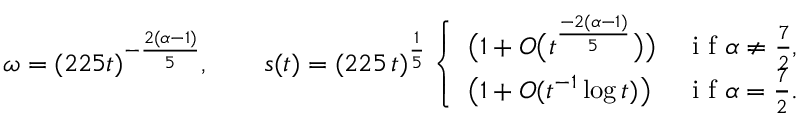Convert formula to latex. <formula><loc_0><loc_0><loc_500><loc_500>\omega = ( 2 2 5 t ) ^ { - \frac { 2 ( \alpha - 1 ) } { 5 } } , \quad s ( t ) = ( 2 2 5 \, t ) ^ { \frac { 1 } { 5 } } \left \{ \begin{array} { l l } { \left ( 1 + O \left ( t ^ { \frac { - 2 ( \alpha - 1 ) } { 5 } } \right ) \right ) } & { i f \alpha \ne \frac { 7 } { 2 } , } \\ { \left ( 1 + O ( t ^ { - 1 } \log t ) \right ) } & { i f \alpha = \frac { 7 } { 2 } . } \end{array}</formula> 